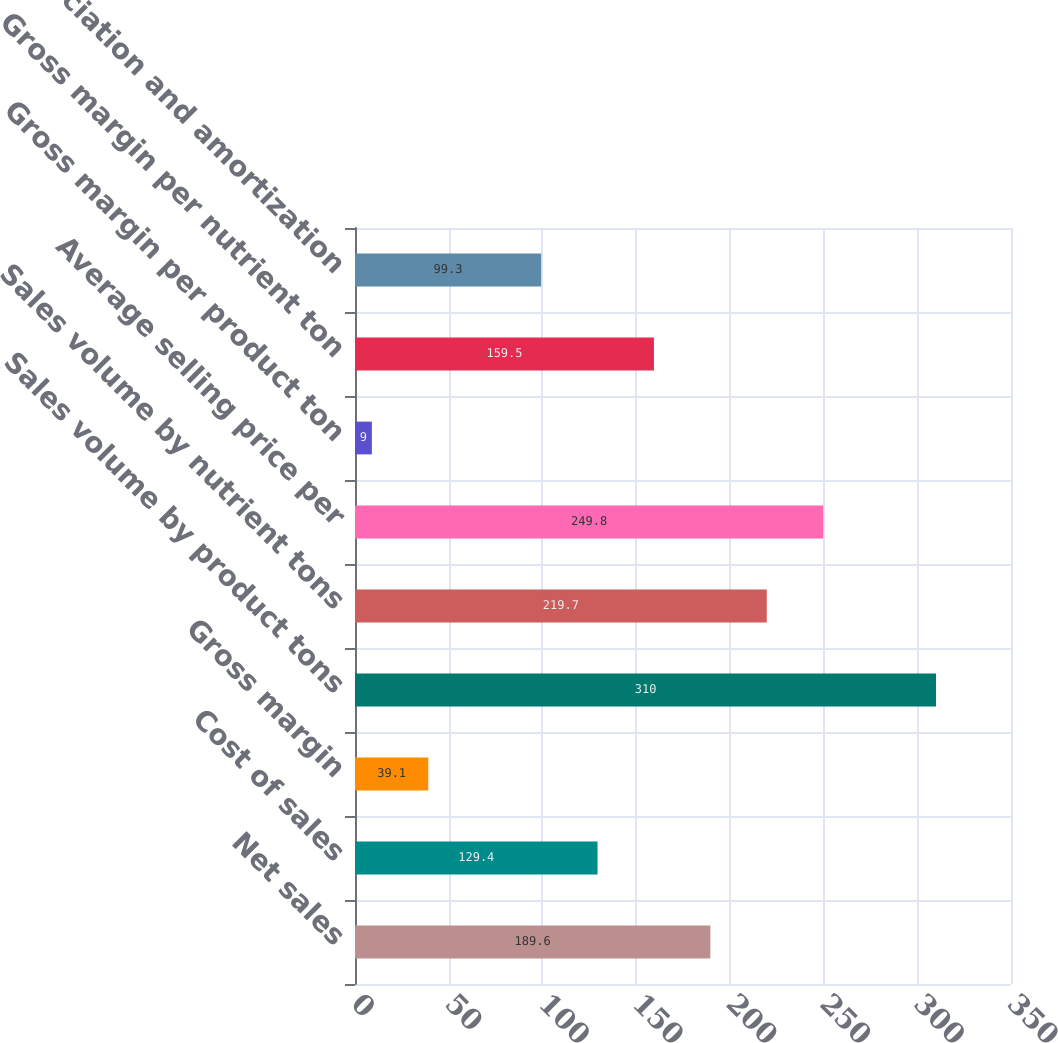Convert chart. <chart><loc_0><loc_0><loc_500><loc_500><bar_chart><fcel>Net sales<fcel>Cost of sales<fcel>Gross margin<fcel>Sales volume by product tons<fcel>Sales volume by nutrient tons<fcel>Average selling price per<fcel>Gross margin per product ton<fcel>Gross margin per nutrient ton<fcel>Depreciation and amortization<nl><fcel>189.6<fcel>129.4<fcel>39.1<fcel>310<fcel>219.7<fcel>249.8<fcel>9<fcel>159.5<fcel>99.3<nl></chart> 